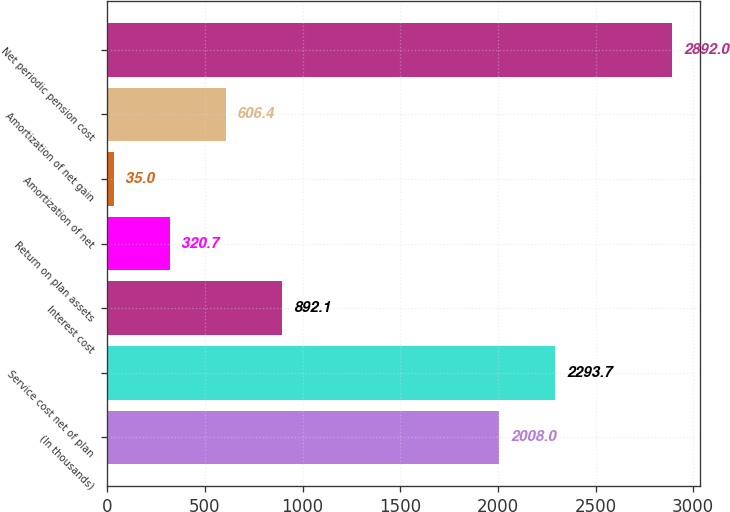Convert chart. <chart><loc_0><loc_0><loc_500><loc_500><bar_chart><fcel>(In thousands)<fcel>Service cost net of plan<fcel>Interest cost<fcel>Return on plan assets<fcel>Amortization of net<fcel>Amortization of net gain<fcel>Net periodic pension cost<nl><fcel>2008<fcel>2293.7<fcel>892.1<fcel>320.7<fcel>35<fcel>606.4<fcel>2892<nl></chart> 